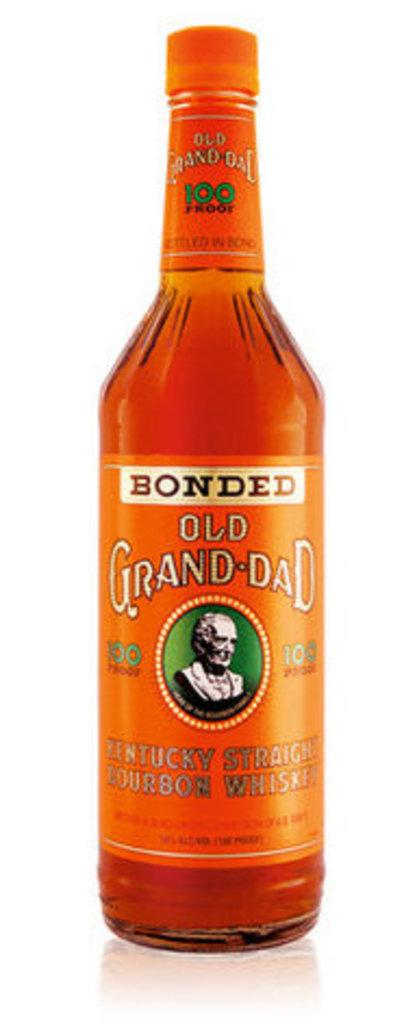<image>
Relay a brief, clear account of the picture shown. A bottle of Old Grand Dad Bourbon whiskey with orange labels. 